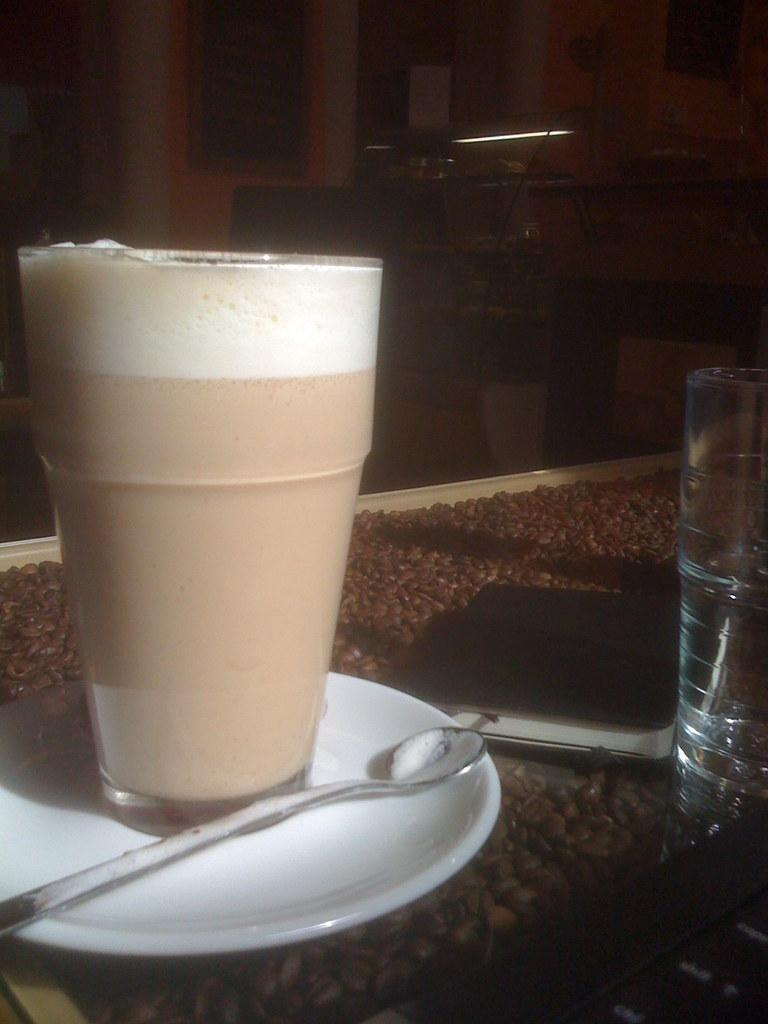What objects are in a saucer in the image? There is a glass and a spoon in a saucer in the image. How many glasses can be seen in the image? There are two glasses in the image. What is placed on the surface in the image? There is a book on the surface in the image. What is attached to the wall in the background of the image? There is a frame attached to the wall in the background of the image. What type of copper material is used to make the book in the image? The book in the image is not made of copper; it is made of paper or other materials typically used for books. 